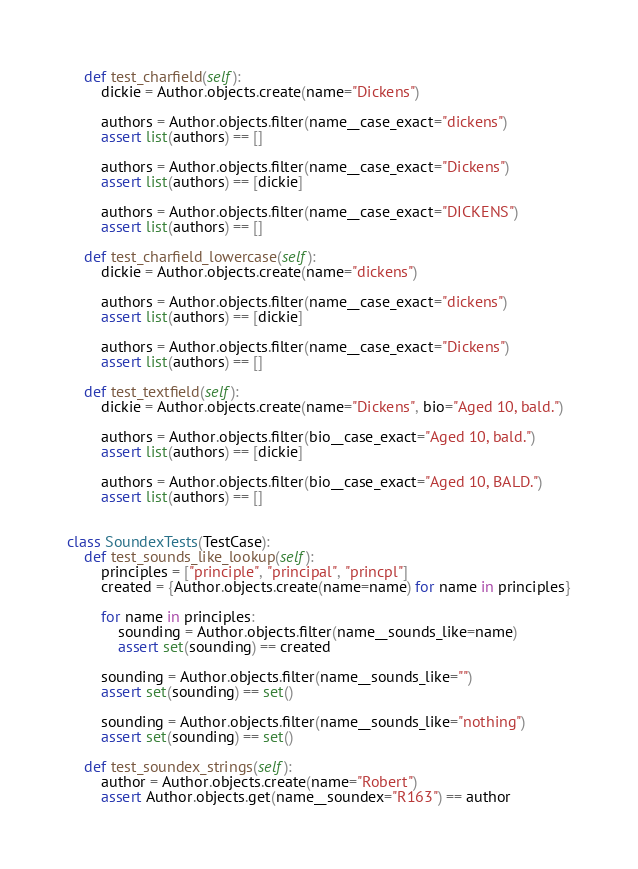Convert code to text. <code><loc_0><loc_0><loc_500><loc_500><_Python_>    def test_charfield(self):
        dickie = Author.objects.create(name="Dickens")

        authors = Author.objects.filter(name__case_exact="dickens")
        assert list(authors) == []

        authors = Author.objects.filter(name__case_exact="Dickens")
        assert list(authors) == [dickie]

        authors = Author.objects.filter(name__case_exact="DICKENS")
        assert list(authors) == []

    def test_charfield_lowercase(self):
        dickie = Author.objects.create(name="dickens")

        authors = Author.objects.filter(name__case_exact="dickens")
        assert list(authors) == [dickie]

        authors = Author.objects.filter(name__case_exact="Dickens")
        assert list(authors) == []

    def test_textfield(self):
        dickie = Author.objects.create(name="Dickens", bio="Aged 10, bald.")

        authors = Author.objects.filter(bio__case_exact="Aged 10, bald.")
        assert list(authors) == [dickie]

        authors = Author.objects.filter(bio__case_exact="Aged 10, BALD.")
        assert list(authors) == []


class SoundexTests(TestCase):
    def test_sounds_like_lookup(self):
        principles = ["principle", "principal", "princpl"]
        created = {Author.objects.create(name=name) for name in principles}

        for name in principles:
            sounding = Author.objects.filter(name__sounds_like=name)
            assert set(sounding) == created

        sounding = Author.objects.filter(name__sounds_like="")
        assert set(sounding) == set()

        sounding = Author.objects.filter(name__sounds_like="nothing")
        assert set(sounding) == set()

    def test_soundex_strings(self):
        author = Author.objects.create(name="Robert")
        assert Author.objects.get(name__soundex="R163") == author
</code> 